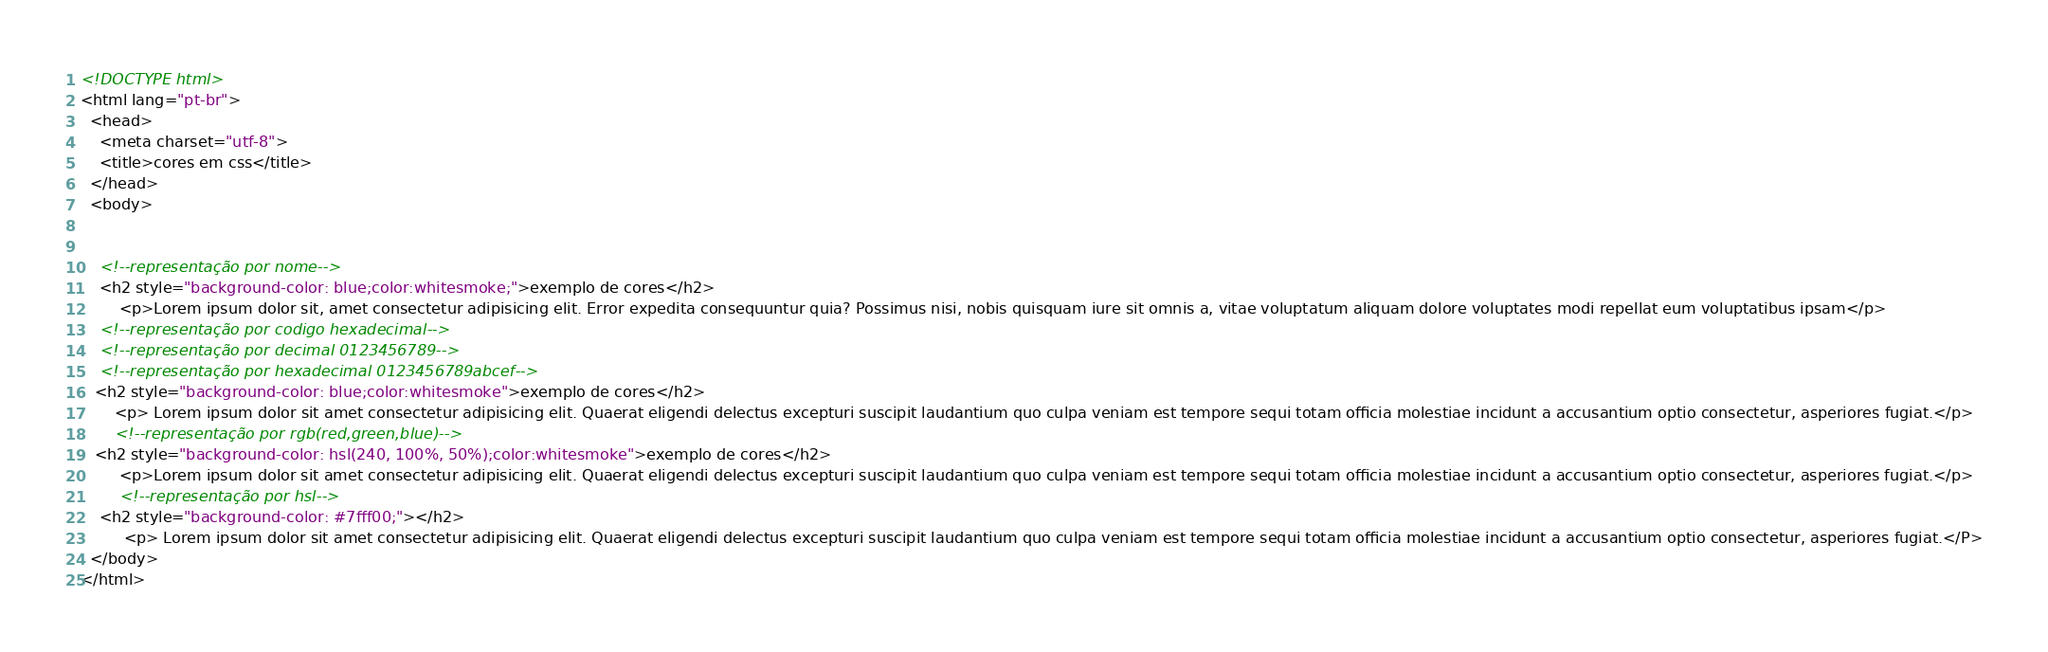<code> <loc_0><loc_0><loc_500><loc_500><_HTML_><!DOCTYPE html>
<html lang="pt-br">
  <head>
    <meta charset="utf-8">
    <title>cores em css</title>
  </head>
  <body>
    
    
    <!--representação por nome-->
    <h2 style="background-color: blue;color:whitesmoke;">exemplo de cores</h2>
        <p>Lorem ipsum dolor sit, amet consectetur adipisicing elit. Error expedita consequuntur quia? Possimus nisi, nobis quisquam iure sit omnis a, vitae voluptatum aliquam dolore voluptates modi repellat eum voluptatibus ipsam</p>
    <!--representação por codigo hexadecimal-->
    <!--representação por decimal 0123456789-->
    <!--representação por hexadecimal 0123456789abcef--> 
   <h2 style="background-color: blue;color:whitesmoke">exemplo de cores</h2>
       <p> Lorem ipsum dolor sit amet consectetur adipisicing elit. Quaerat eligendi delectus excepturi suscipit laudantium quo culpa veniam est tempore sequi totam officia molestiae incidunt a accusantium optio consectetur, asperiores fugiat.</p>
       <!--representação por rgb(red,green,blue)--> 
   <h2 style="background-color: hsl(240, 100%, 50%);color:whitesmoke">exemplo de cores</h2>
        <p>Lorem ipsum dolor sit amet consectetur adipisicing elit. Quaerat eligendi delectus excepturi suscipit laudantium quo culpa veniam est tempore sequi totam officia molestiae incidunt a accusantium optio consectetur, asperiores fugiat.</p>
        <!--representação por hsl-->
    <h2 style="background-color: #7fff00;"></h2>
         <p> Lorem ipsum dolor sit amet consectetur adipisicing elit. Quaerat eligendi delectus excepturi suscipit laudantium quo culpa veniam est tempore sequi totam officia molestiae incidunt a accusantium optio consectetur, asperiores fugiat.</P>
  </body>
</html></code> 